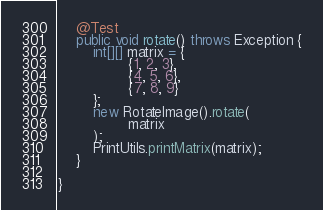Convert code to text. <code><loc_0><loc_0><loc_500><loc_500><_Java_>    @Test
    public void rotate() throws Exception {
        int[][] matrix = {
                {1, 2, 3},
                {4, 5, 6},
                {7, 8, 9}
        };
        new RotateImage().rotate(
                matrix
        );
        PrintUtils.printMatrix(matrix);
    }

}</code> 